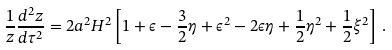<formula> <loc_0><loc_0><loc_500><loc_500>\frac { 1 } { z } \frac { d ^ { 2 } z } { d \tau ^ { 2 } } = 2 a ^ { 2 } H ^ { 2 } \left [ 1 + \epsilon - \frac { 3 } { 2 } \eta + \epsilon ^ { 2 } - 2 \epsilon \eta + \frac { 1 } { 2 } \eta ^ { 2 } + \frac { 1 } { 2 } \xi ^ { 2 } \right ] \, .</formula> 